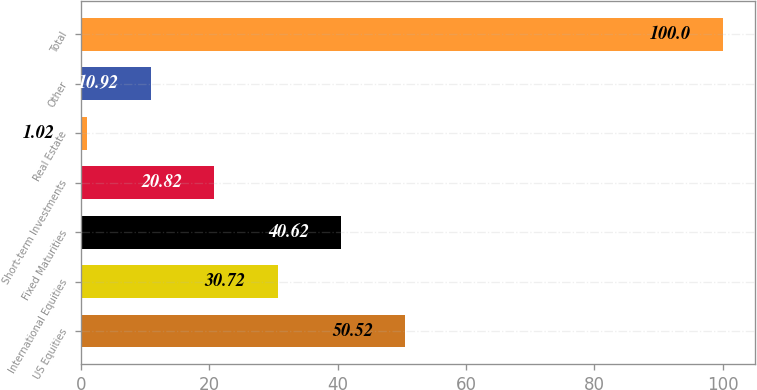Convert chart to OTSL. <chart><loc_0><loc_0><loc_500><loc_500><bar_chart><fcel>US Equities<fcel>International Equities<fcel>Fixed Maturities<fcel>Short-term Investments<fcel>Real Estate<fcel>Other<fcel>Total<nl><fcel>50.52<fcel>30.72<fcel>40.62<fcel>20.82<fcel>1.02<fcel>10.92<fcel>100<nl></chart> 